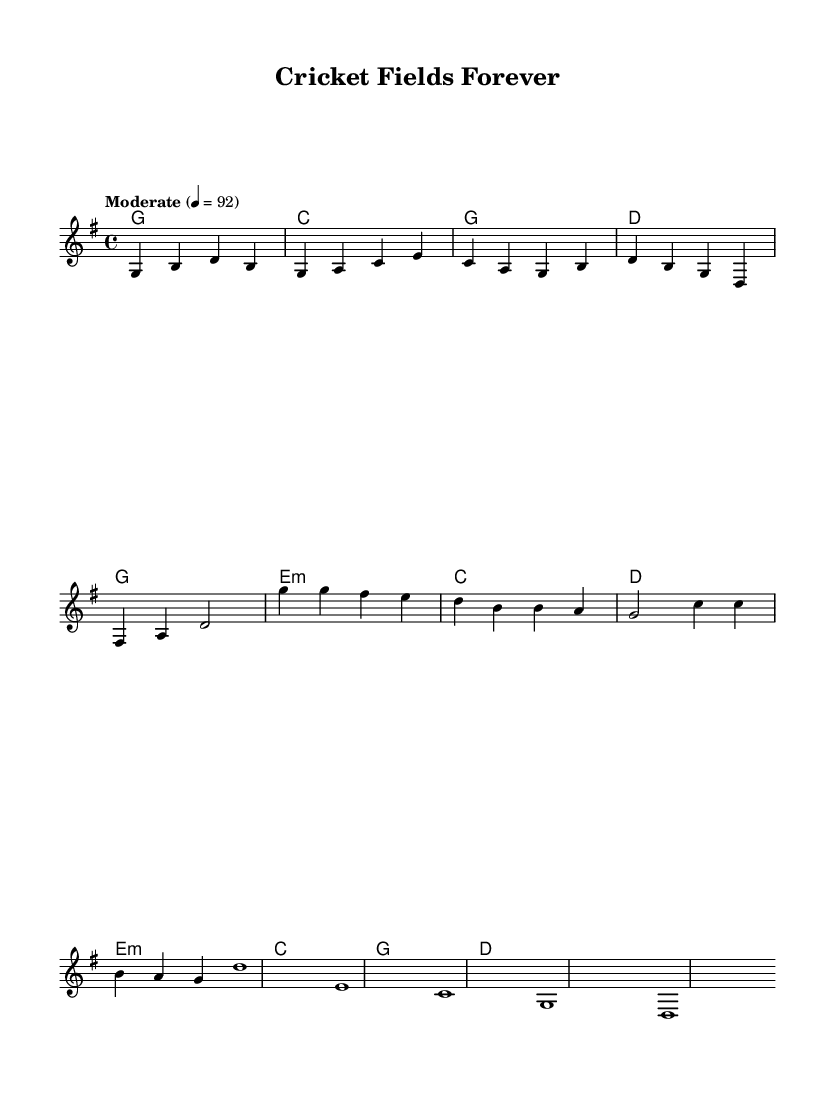What is the key signature of this music? The key signature is G major, which has one sharp (F#). This is determined by looking at the key indicated in the global settings of the sheet music.
Answer: G major What is the time signature of this music? The time signature is 4/4, which is indicated at the beginning of the global settings. It means there are four beats in each measure and a quarter note receives one beat.
Answer: 4/4 What is the tempo marking of the piece? The tempo marking is "Moderate" 4 = 92, shown at the global section which indicates how fast the music should be played.
Answer: Moderate 4 = 92 How many measures are in the first verse? There are four measures in the first verse, as counted in the melody section where it's divided into segments with vertical bar lines.
Answer: 4 What chords are used in the chorus? The chords used in the chorus are G, E minor, C, and D, which can be found in the harmonies section related to the chorus section.
Answer: G, E minor, C, D Which section follows the verse in the structure of the song? The section that follows the verse is the chorus, as established by the layout of the music where the verse is completed before moving on to the chorus.
Answer: Chorus What is the first note of the melody? The first note of the melody is G, which is seen at the start of the melody notation in the relative pitch.
Answer: G 